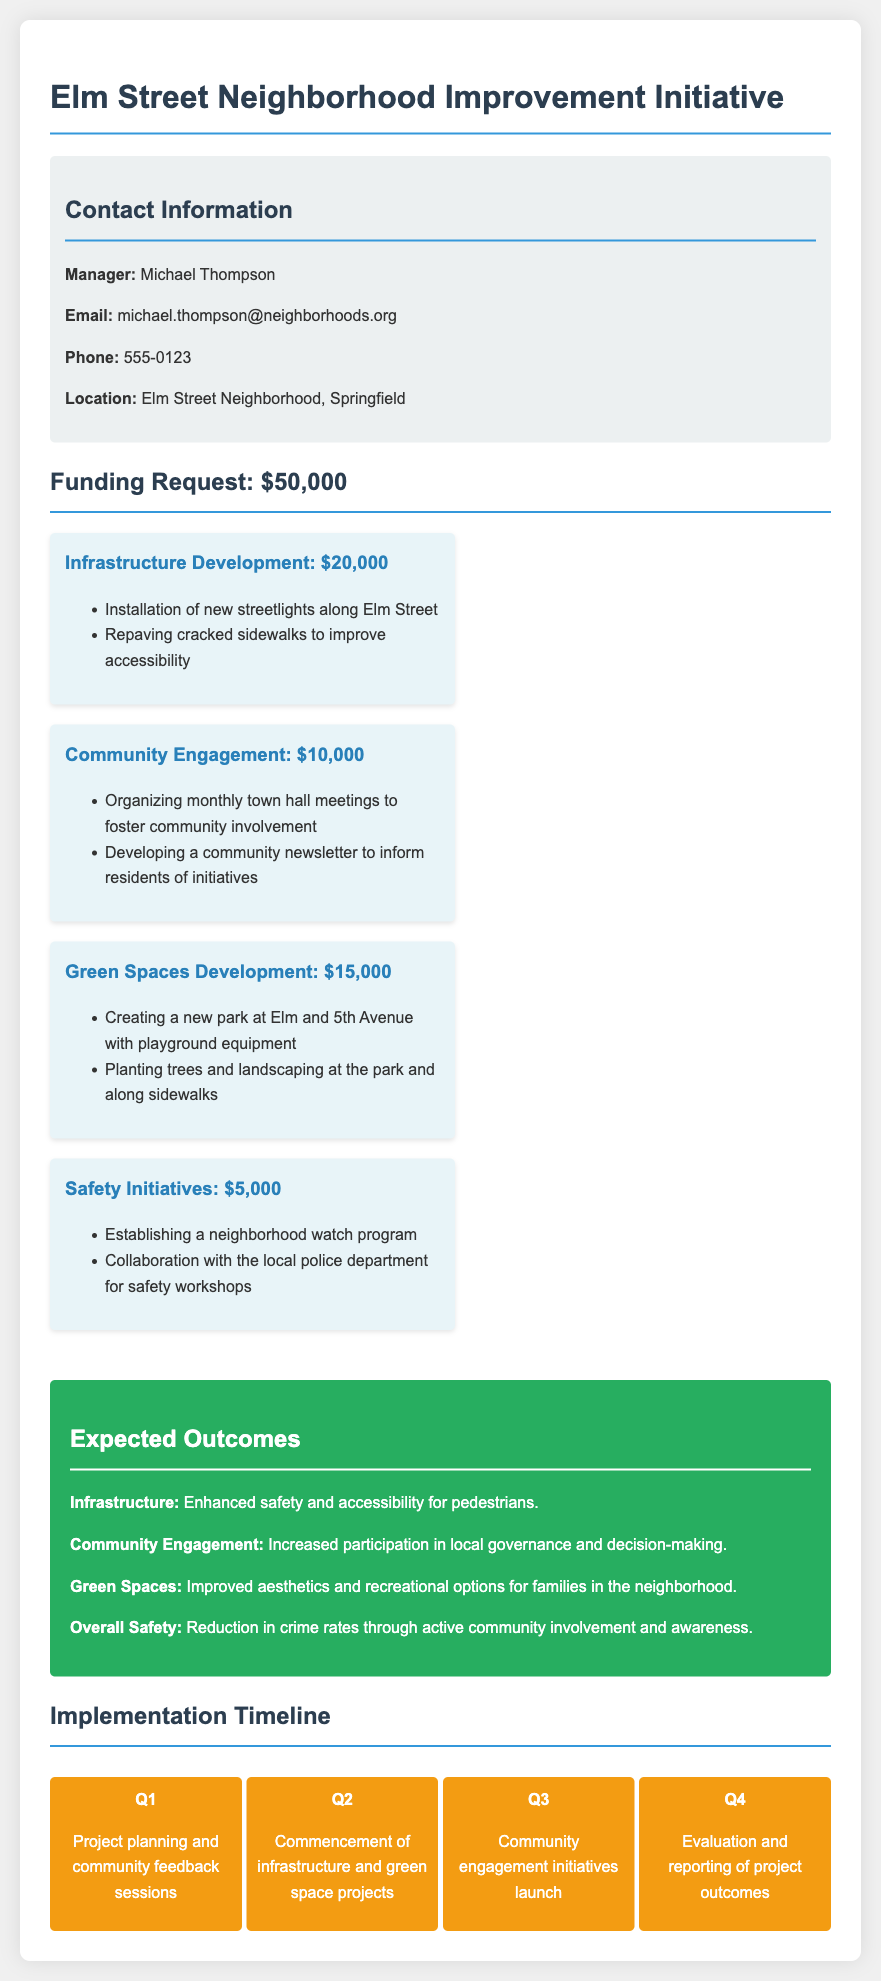What is the total funding request? The total funding request is stated in the document as $50,000.
Answer: $50,000 Who is the manager listed in the contact information? The manager's name is mentioned in the contact section as Michael Thompson.
Answer: Michael Thompson What is the budget allocation for Community Engagement? The budget for Community Engagement is detailed in the funding breakdown as $10,000.
Answer: $10,000 What is one expected outcome related to infrastructure? The document specifies that the expected outcome for infrastructure is enhanced safety and accessibility for pedestrians.
Answer: Enhanced safety and accessibility for pedestrians In which quarter does the project planning occur? According to the implementation timeline, project planning is scheduled for Q1.
Answer: Q1 What is the location of the neighborhood improvement initiative? The document clearly states that the location is Elm Street Neighborhood, Springfield.
Answer: Elm Street Neighborhood, Springfield How much funding is allocated for Safety Initiatives? The funding for Safety Initiatives is listed as $5,000 in the breakdown.
Answer: $5,000 What is the purpose of the neighborhood watch program? The document indicates that the neighborhood watch program aims to enhance safety initiatives.
Answer: Enhance safety initiatives 